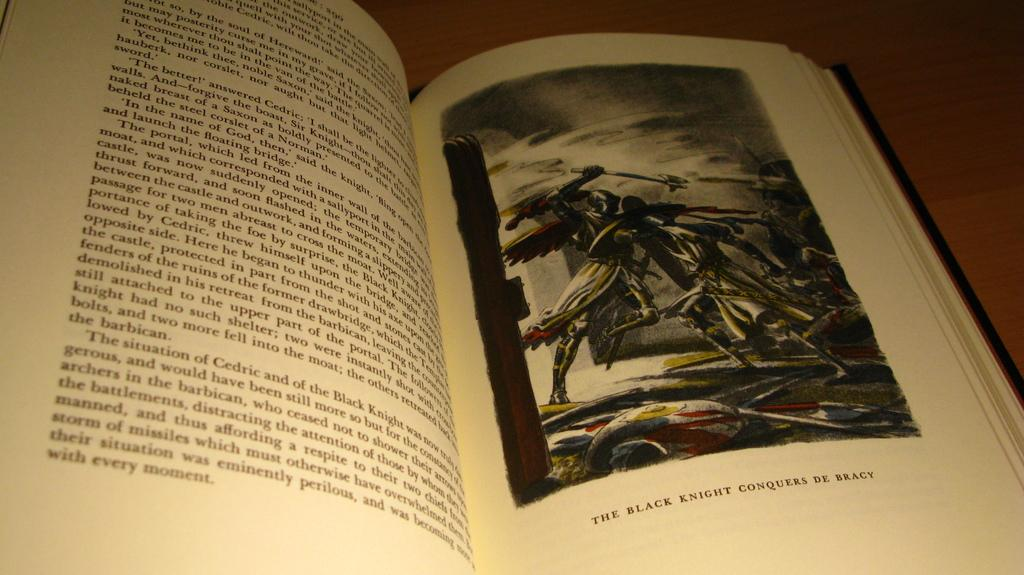<image>
Render a clear and concise summary of the photo. A book sits open to a page with a picture of The black night conquers De Bracy. 